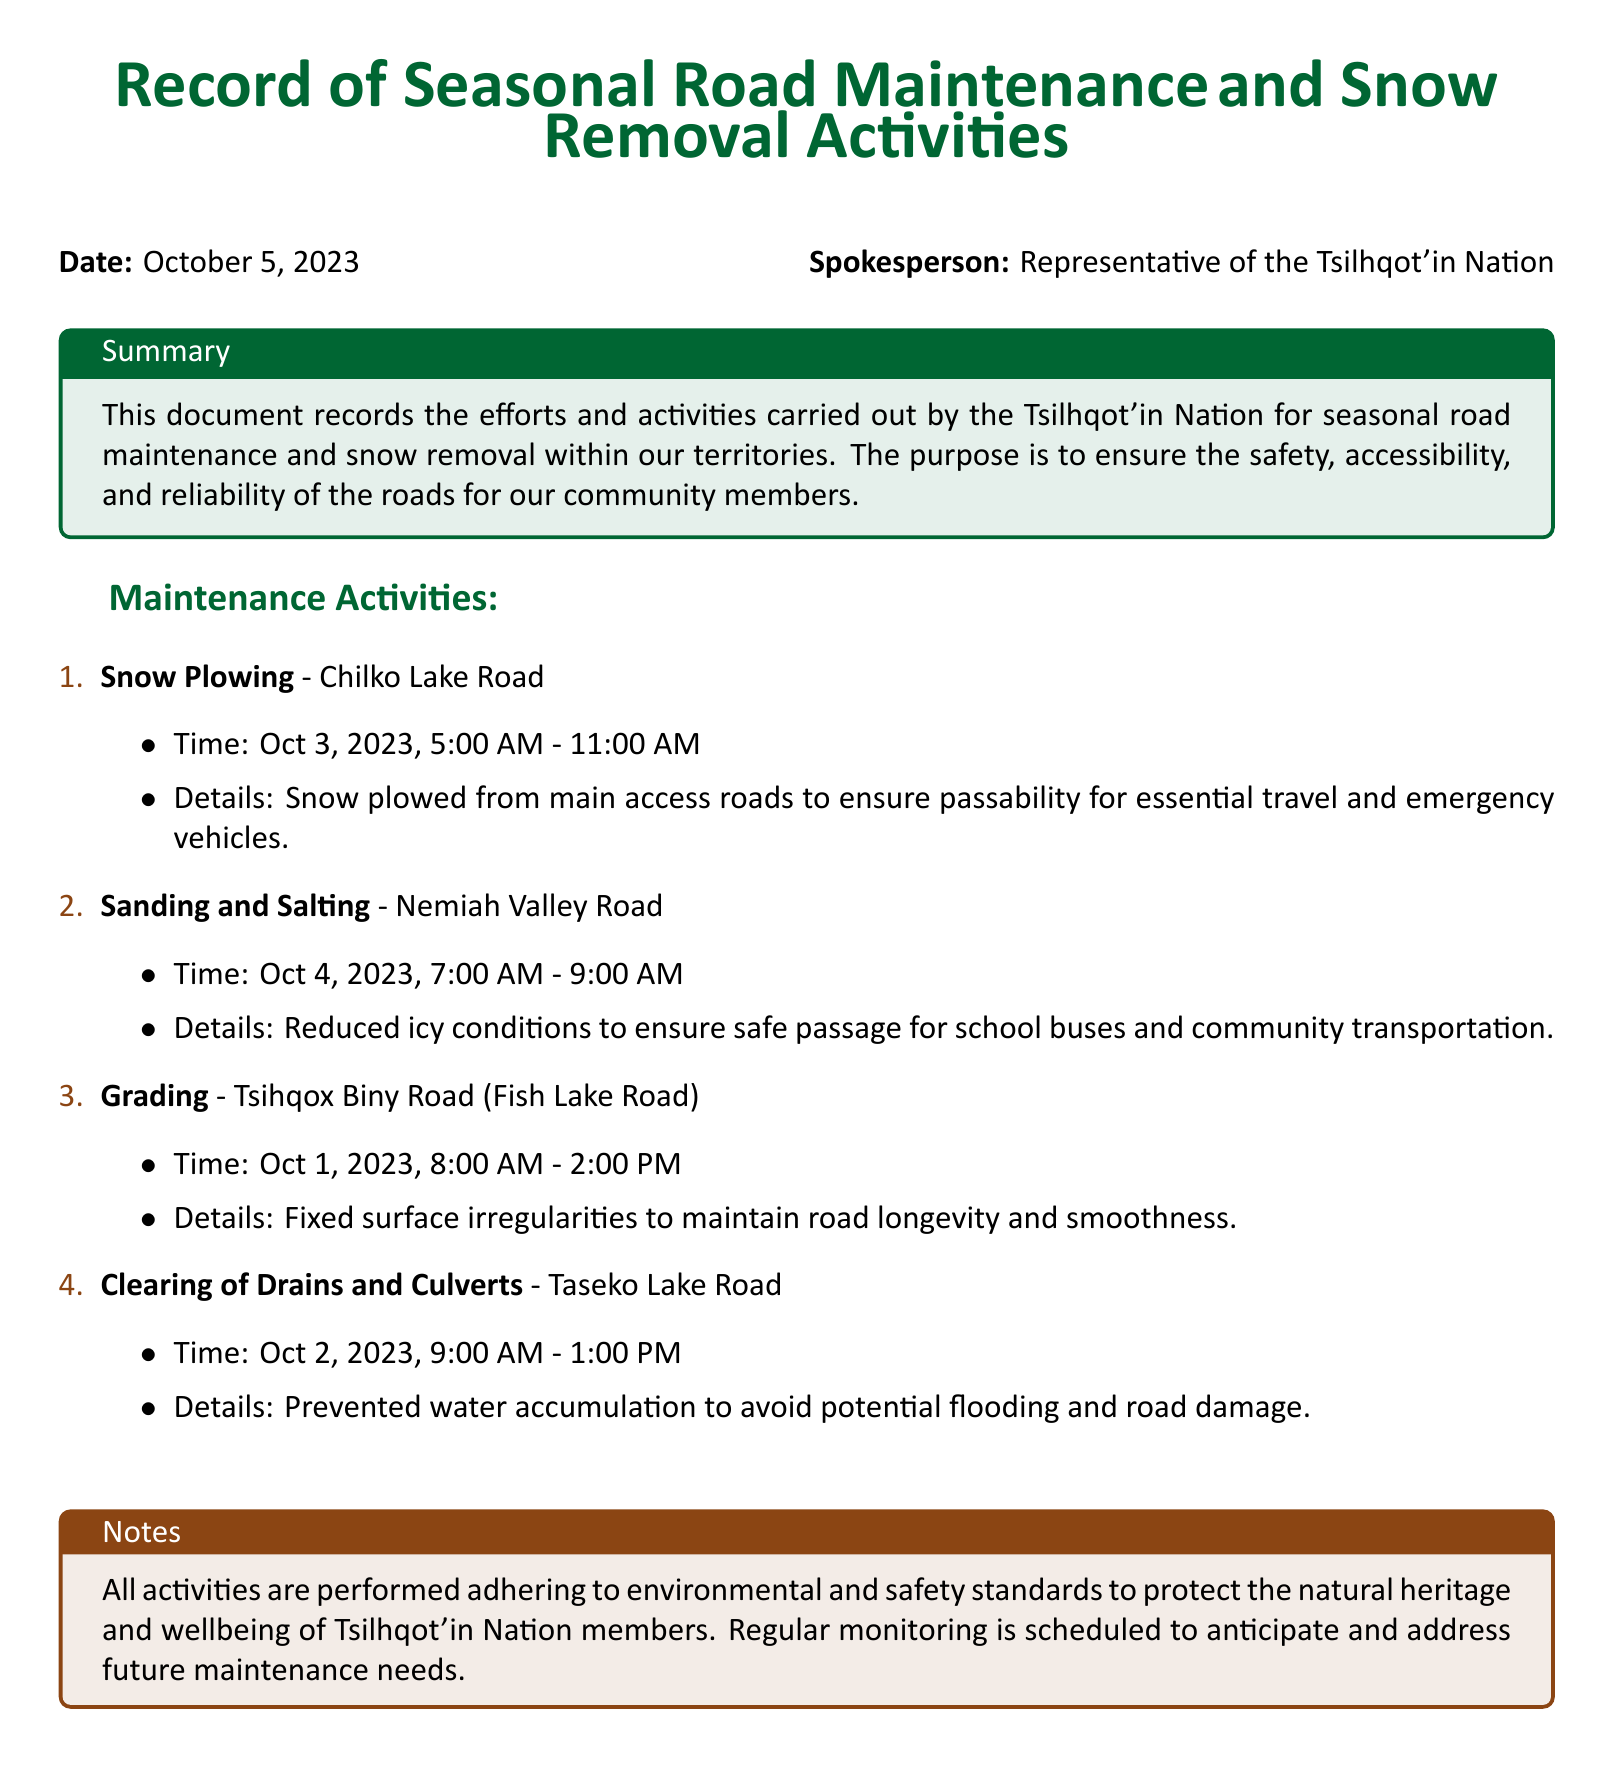What is the date of the record? The date is mentioned at the beginning of the document.
Answer: October 5, 2023 Who is the spokesperson? The spokesperson's name is identified following the date.
Answer: Representative of the Tsilhqot'in Nation What maintenance activity took place on October 3, 2023? The activities are listed with corresponding dates, and the one for October 3 is snow plowing.
Answer: Snow Plowing How long was the sanding and salting activity? The time for the sanding and salting activity is specified in the document.
Answer: 2 hours Which road was graded according to the log? Roads mentioned under each activity detail the specific locations.
Answer: Tsihqox Biny Road (Fish Lake Road) What is one reason for clearing drains and culverts? The details provided explain the purpose of the activity.
Answer: Prevented water accumulation Which activity ensures safe passage for school buses? The document outlines which activity corresponds to safe travel for school buses.
Answer: Sanding and Salting What is the goal of road maintenance and snow removal activities? The purpose is summarized in the introduction box of the document.
Answer: Ensure safety, accessibility, and reliability of the roads Are the maintenance activities compliant with environmental standards? The notes section indicates adherence to specific standards for the activities.
Answer: Yes 